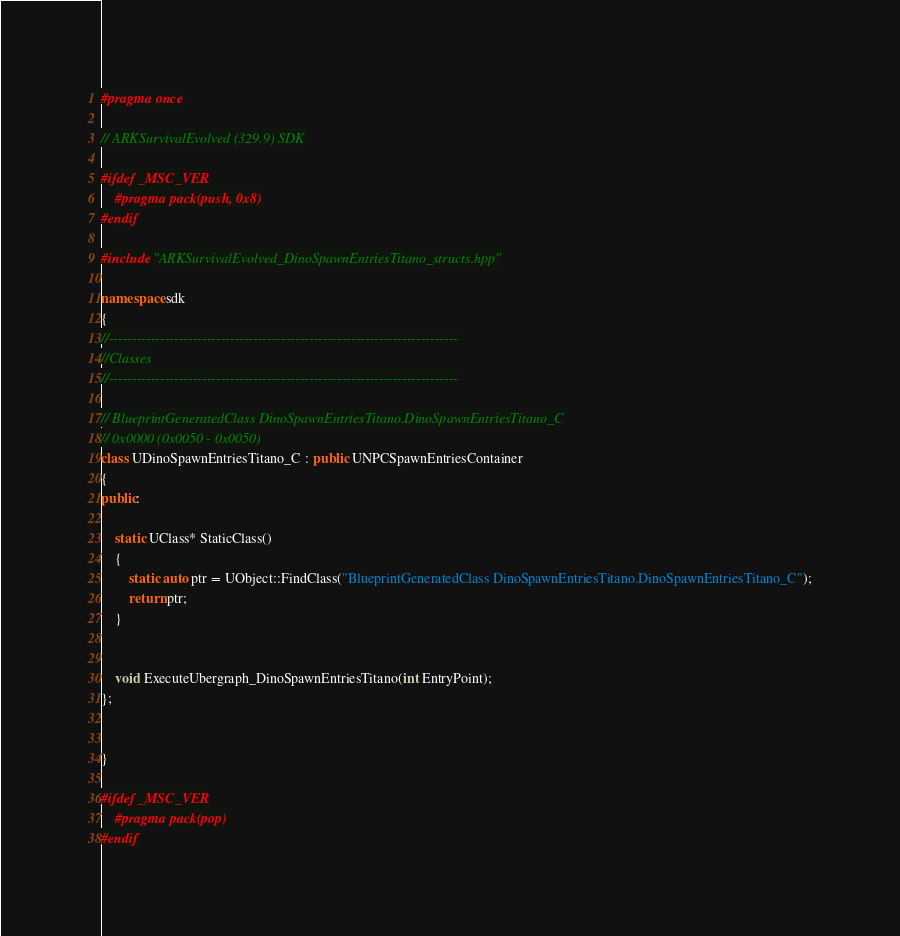<code> <loc_0><loc_0><loc_500><loc_500><_C++_>#pragma once

// ARKSurvivalEvolved (329.9) SDK

#ifdef _MSC_VER
	#pragma pack(push, 0x8)
#endif

#include "ARKSurvivalEvolved_DinoSpawnEntriesTitano_structs.hpp"

namespace sdk
{
//---------------------------------------------------------------------------
//Classes
//---------------------------------------------------------------------------

// BlueprintGeneratedClass DinoSpawnEntriesTitano.DinoSpawnEntriesTitano_C
// 0x0000 (0x0050 - 0x0050)
class UDinoSpawnEntriesTitano_C : public UNPCSpawnEntriesContainer
{
public:

	static UClass* StaticClass()
	{
		static auto ptr = UObject::FindClass("BlueprintGeneratedClass DinoSpawnEntriesTitano.DinoSpawnEntriesTitano_C");
		return ptr;
	}


	void ExecuteUbergraph_DinoSpawnEntriesTitano(int EntryPoint);
};


}

#ifdef _MSC_VER
	#pragma pack(pop)
#endif
</code> 